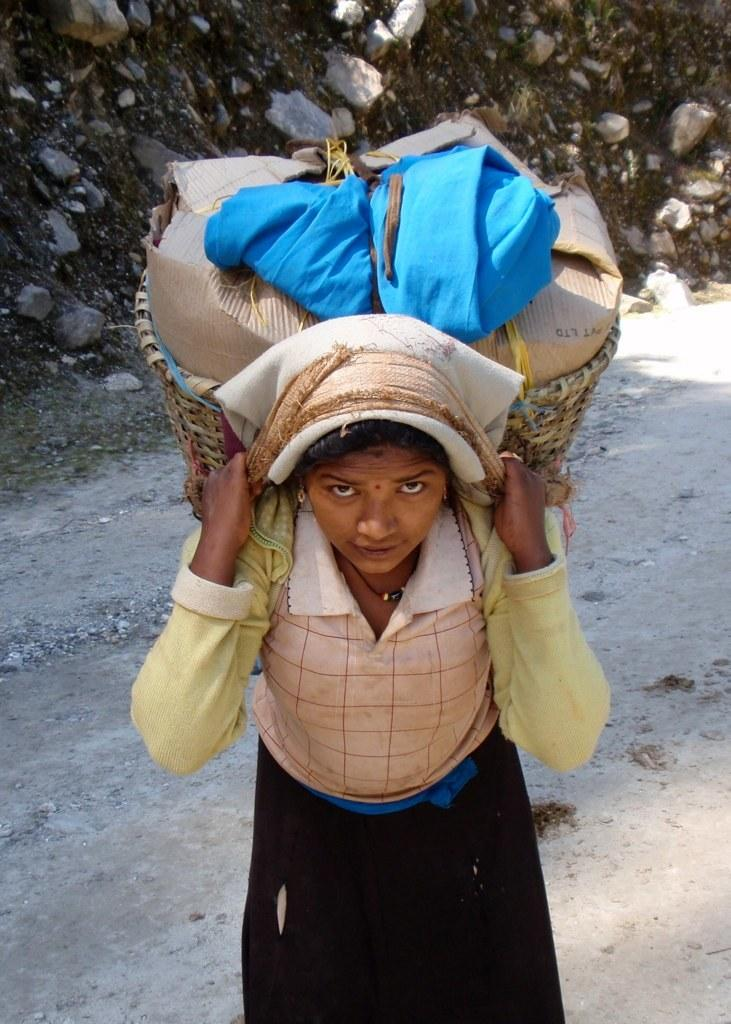Who is the main subject in the picture? There is a woman in the picture. What is the woman carrying in the image? The woman is carrying a jute basket. What can be found inside the jute basket? There are items in the jute basket. What is visible in the background behind the woman? There are stones present behind the woman. How does the woman react to the surprise in the image? There is no mention of a surprise in the image, so it is not possible to determine how the woman might react. 